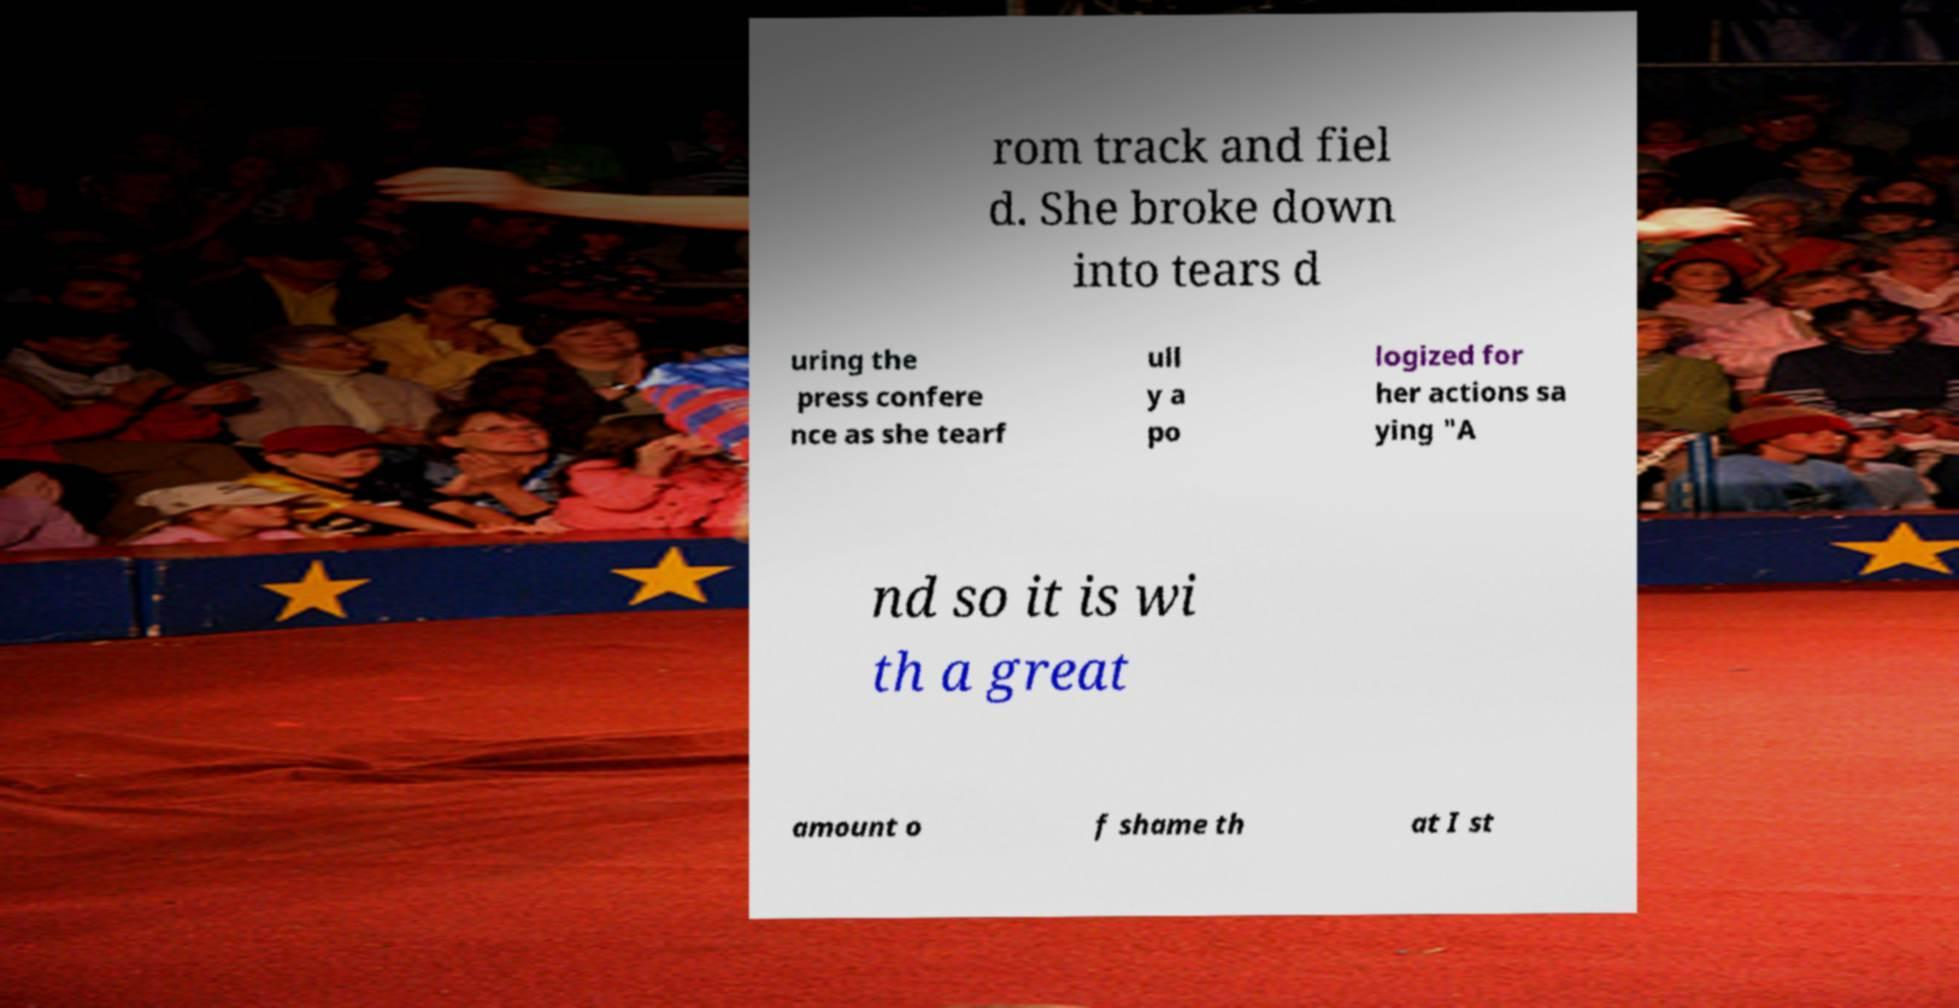What messages or text are displayed in this image? I need them in a readable, typed format. rom track and fiel d. She broke down into tears d uring the press confere nce as she tearf ull y a po logized for her actions sa ying "A nd so it is wi th a great amount o f shame th at I st 